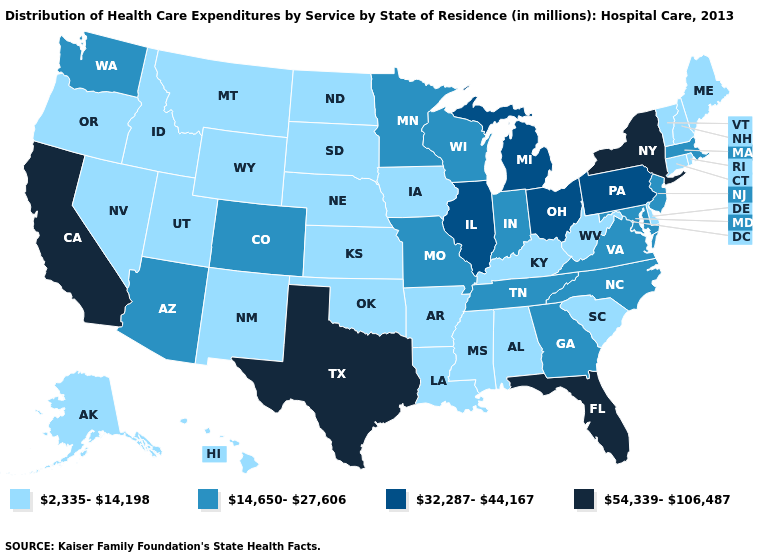How many symbols are there in the legend?
Short answer required. 4. Does the map have missing data?
Answer briefly. No. What is the value of Georgia?
Be succinct. 14,650-27,606. What is the value of California?
Be succinct. 54,339-106,487. What is the value of Alaska?
Give a very brief answer. 2,335-14,198. Does Illinois have a higher value than Pennsylvania?
Be succinct. No. Does South Dakota have the highest value in the USA?
Keep it brief. No. What is the value of Virginia?
Short answer required. 14,650-27,606. Which states have the highest value in the USA?
Concise answer only. California, Florida, New York, Texas. What is the lowest value in states that border South Carolina?
Concise answer only. 14,650-27,606. Does Michigan have the lowest value in the USA?
Give a very brief answer. No. Which states have the highest value in the USA?
Answer briefly. California, Florida, New York, Texas. What is the value of Arkansas?
Quick response, please. 2,335-14,198. Which states hav the highest value in the Northeast?
Answer briefly. New York. Name the states that have a value in the range 32,287-44,167?
Short answer required. Illinois, Michigan, Ohio, Pennsylvania. 